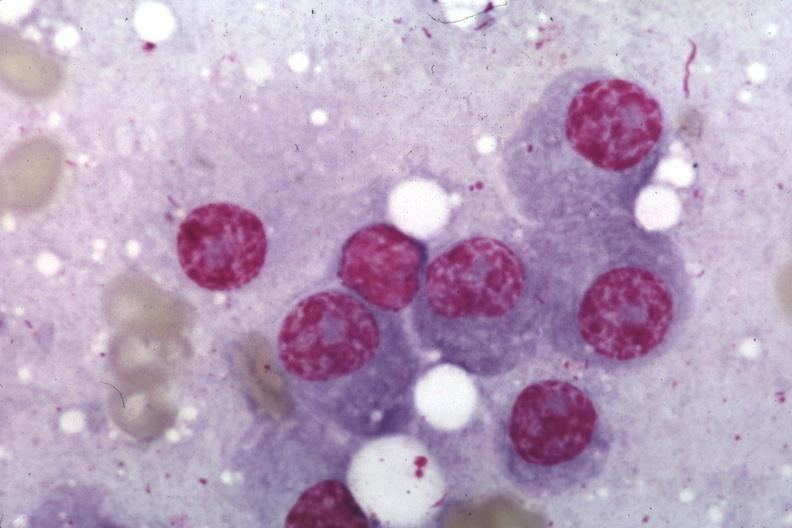s this photo present?
Answer the question using a single word or phrase. No 